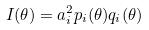<formula> <loc_0><loc_0><loc_500><loc_500>I ( \theta ) = a _ { i } ^ { 2 } p _ { i } ( \theta ) q _ { i } ( \theta )</formula> 